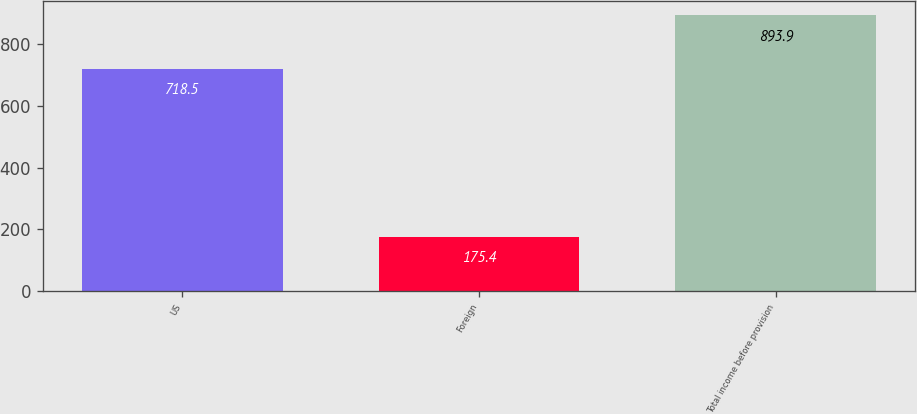Convert chart to OTSL. <chart><loc_0><loc_0><loc_500><loc_500><bar_chart><fcel>US<fcel>Foreign<fcel>Total income before provision<nl><fcel>718.5<fcel>175.4<fcel>893.9<nl></chart> 